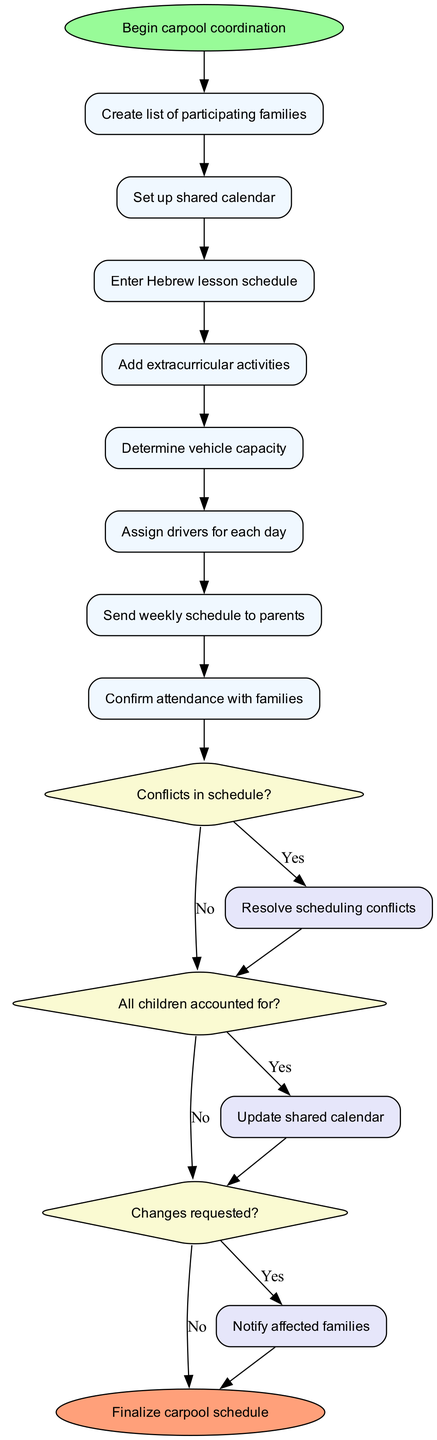What is the first action taken in the carpool coordination process? The diagram clearly indicates that the first action is "Create list of participating families," which follows the start node connected by an edge.
Answer: Create list of participating families How many decision nodes are present in the diagram? The diagram features three decision nodes related to potential conflicts, attendance, and changes requested. Counting these nodes provides the answer.
Answer: 3 What is the last action before any decision nodes are evaluated? The last action before reaching the first decision node is "Send weekly schedule to parents," which is connected by an edge.
Answer: Send weekly schedule to parents What happens if there are changes requested according to the flowchart? If changes are requested in the decision flow, the diagram leads to the "Notify affected families" process, indicating a specific procedure is to be followed upon such requests.
Answer: Notify affected families If there are no conflicts in the schedule, what is the next step? Following the decision node for "Conflicts in schedule?" and a "No" response, the next step in the flowchart is directly to the "All children accounted for?" decision node.
Answer: All children accounted for? What action follows the determination of vehicle capacity? The action that follows determining vehicle capacity in the sequence is "Assign drivers for each day" as shown in the flowchart's linear progression.
Answer: Assign drivers for each day What do you do if all children are accounted for? If all children are accounted for (the decision indicates "Yes"), the flowchart specifies that you would then proceed to finalize the carpool schedule as indicated by the edge leading to the end node.
Answer: Finalize carpool schedule What is the final node in the diagram? The final node in the diagram is labeled "Finalize carpool schedule," showing the endpoint of the coordination process.
Answer: Finalize carpool schedule How does the flowchart handle having unresolved scheduling conflicts? The flowchart indicates that if there are scheduling conflicts (a "Yes" response), the process directs towards "Resolve scheduling conflicts," guiding the action required to address the issue.
Answer: Resolve scheduling conflicts What action is taken after confirming attendance with families? After confirming attendance with families, the flowchart leads to the end node indicating that the coordination process is complete.
Answer: Finalize carpool schedule 